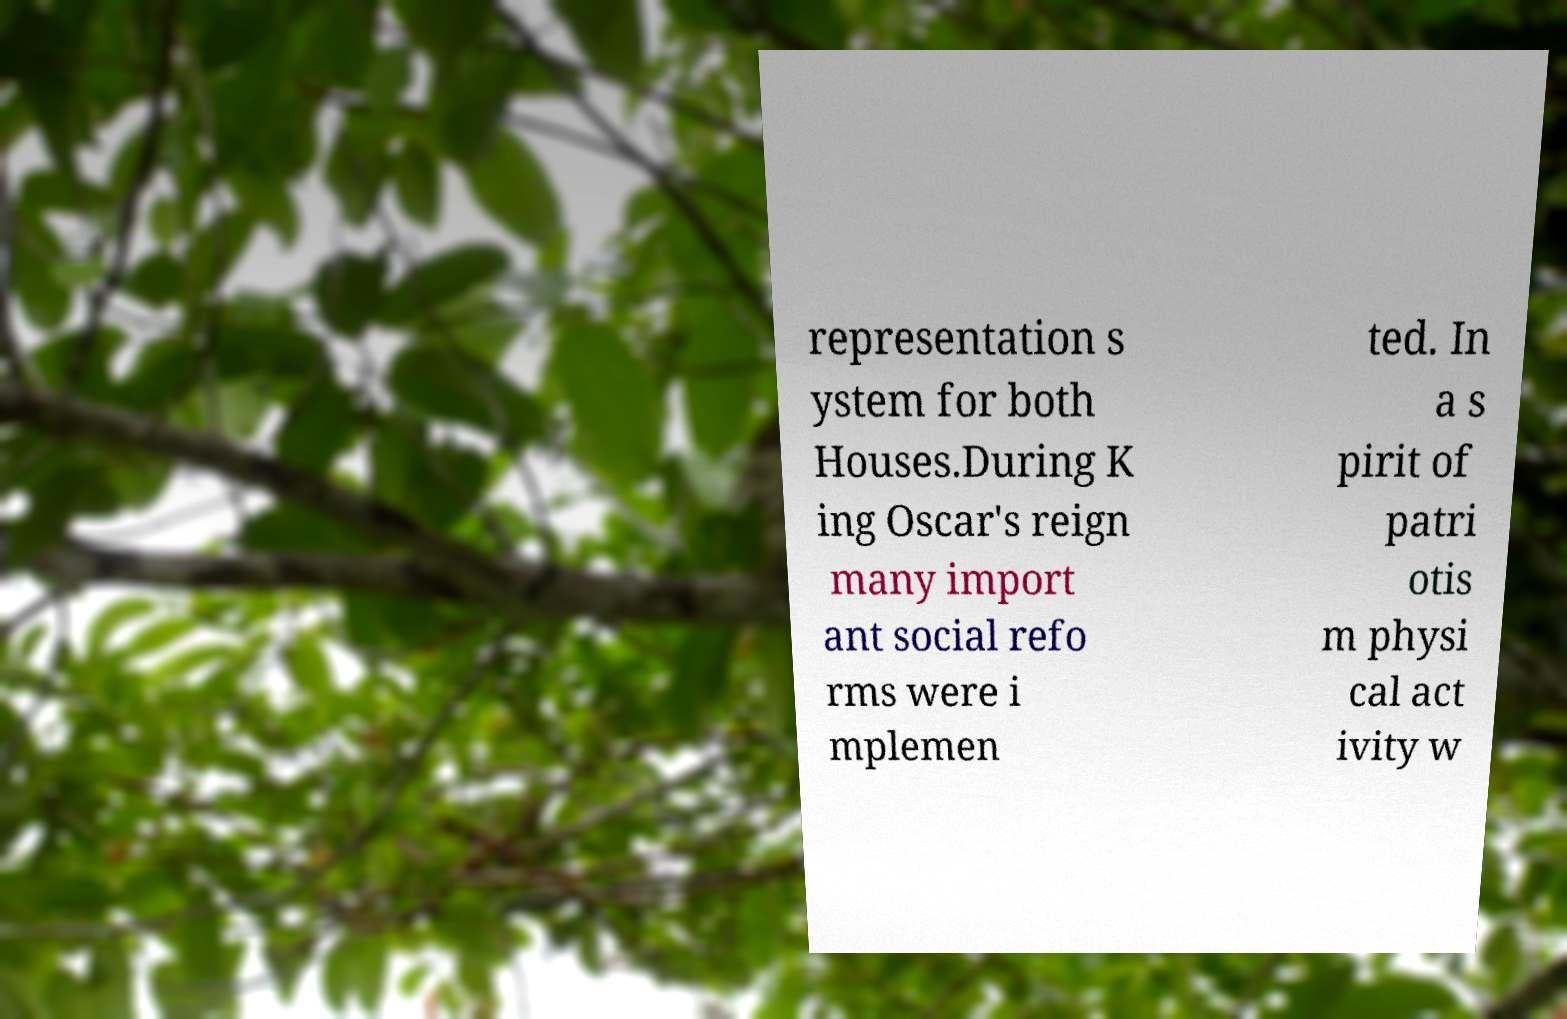Could you extract and type out the text from this image? representation s ystem for both Houses.During K ing Oscar's reign many import ant social refo rms were i mplemen ted. In a s pirit of patri otis m physi cal act ivity w 